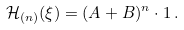Convert formula to latex. <formula><loc_0><loc_0><loc_500><loc_500>\mathcal { H } _ { ( n ) } ( \xi ) = ( A + B ) ^ { n } \cdot 1 \, .</formula> 